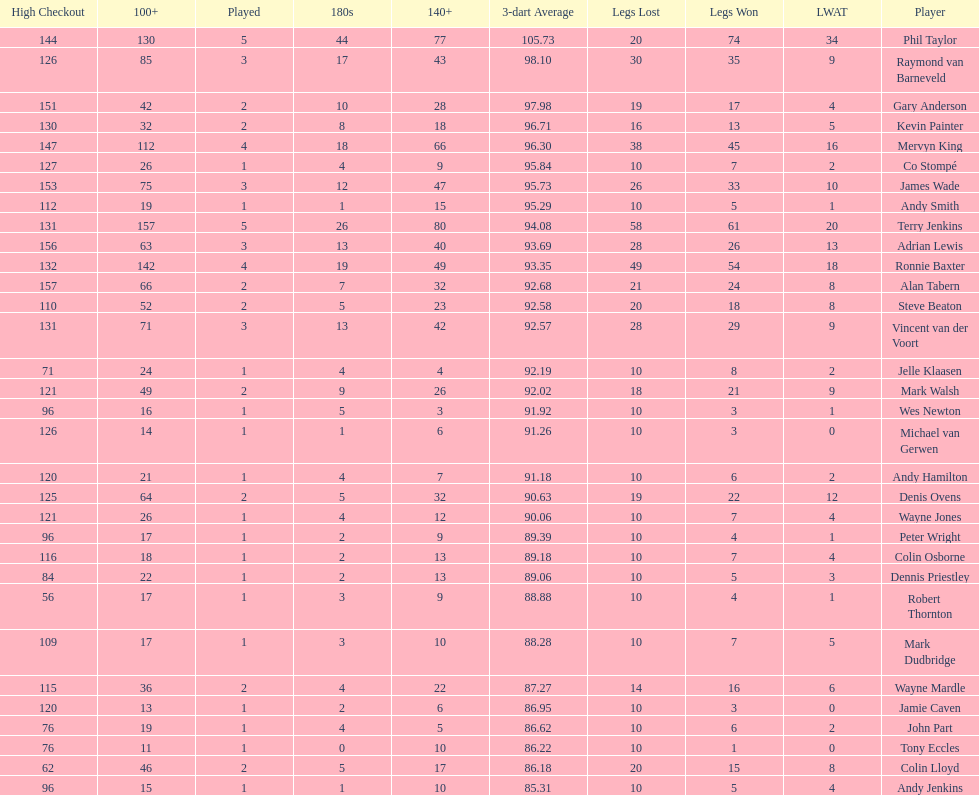Which player lost the least? Co Stompé, Andy Smith, Jelle Klaasen, Wes Newton, Michael van Gerwen, Andy Hamilton, Wayne Jones, Peter Wright, Colin Osborne, Dennis Priestley, Robert Thornton, Mark Dudbridge, Jamie Caven, John Part, Tony Eccles, Andy Jenkins. 